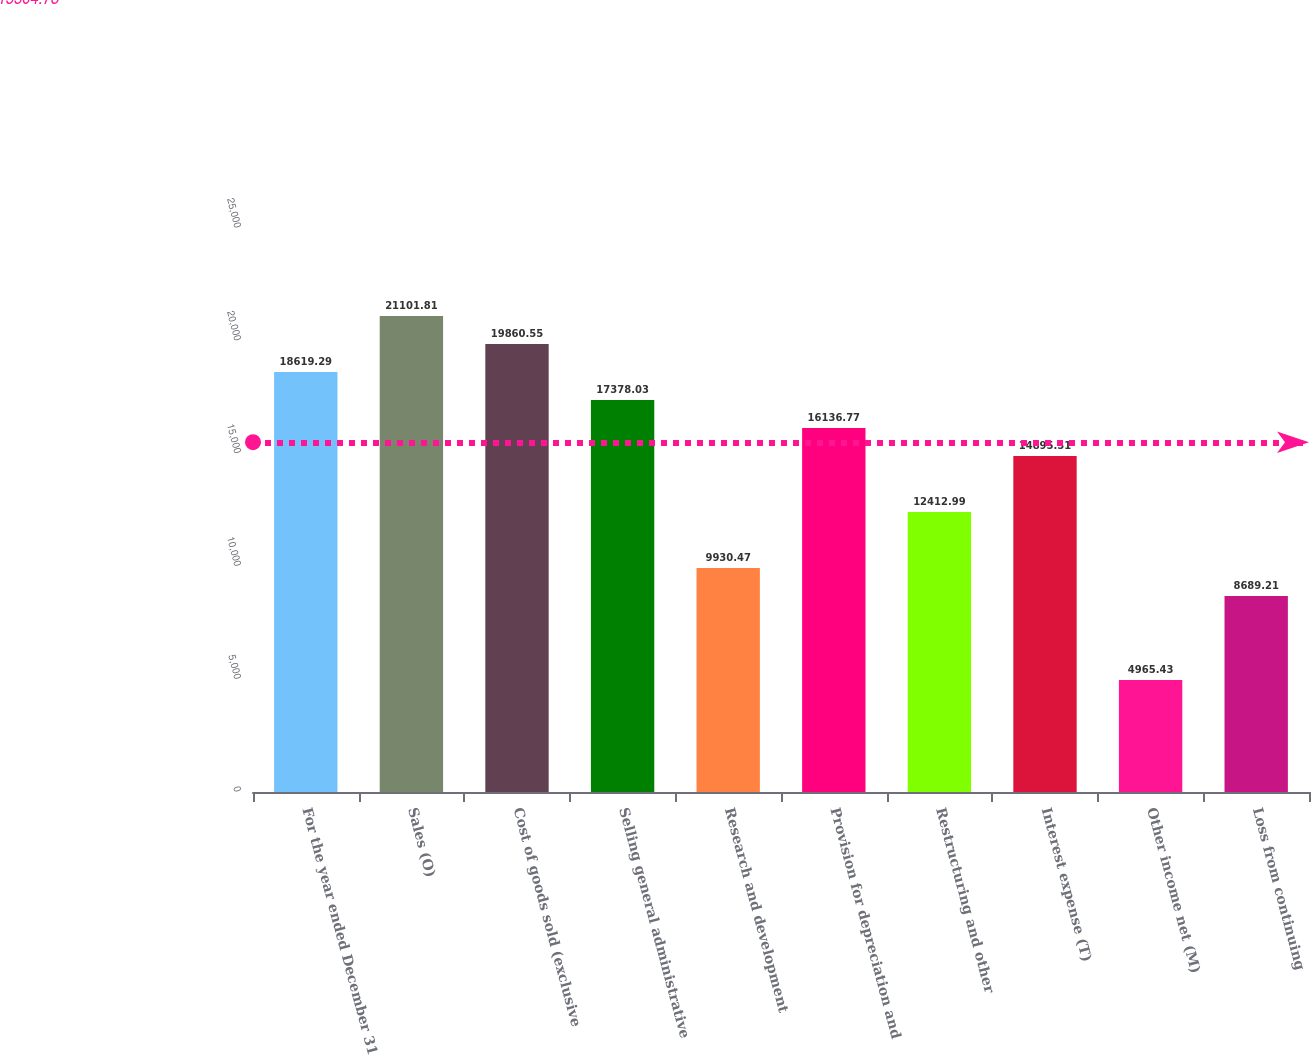Convert chart to OTSL. <chart><loc_0><loc_0><loc_500><loc_500><bar_chart><fcel>For the year ended December 31<fcel>Sales (O)<fcel>Cost of goods sold (exclusive<fcel>Selling general administrative<fcel>Research and development<fcel>Provision for depreciation and<fcel>Restructuring and other<fcel>Interest expense (T)<fcel>Other income net (M)<fcel>Loss from continuing<nl><fcel>18619.3<fcel>21101.8<fcel>19860.5<fcel>17378<fcel>9930.47<fcel>16136.8<fcel>12413<fcel>14895.5<fcel>4965.43<fcel>8689.21<nl></chart> 